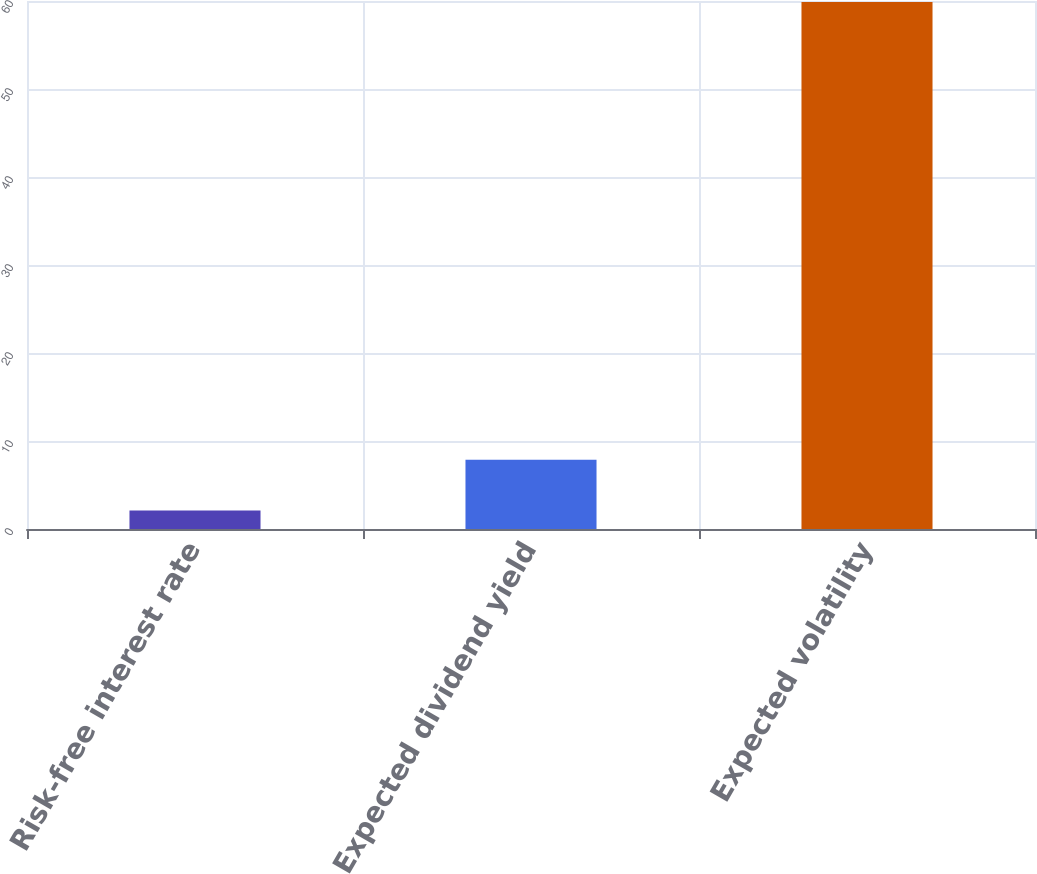Convert chart. <chart><loc_0><loc_0><loc_500><loc_500><bar_chart><fcel>Risk-free interest rate<fcel>Expected dividend yield<fcel>Expected volatility<nl><fcel>2.1<fcel>7.88<fcel>59.9<nl></chart> 